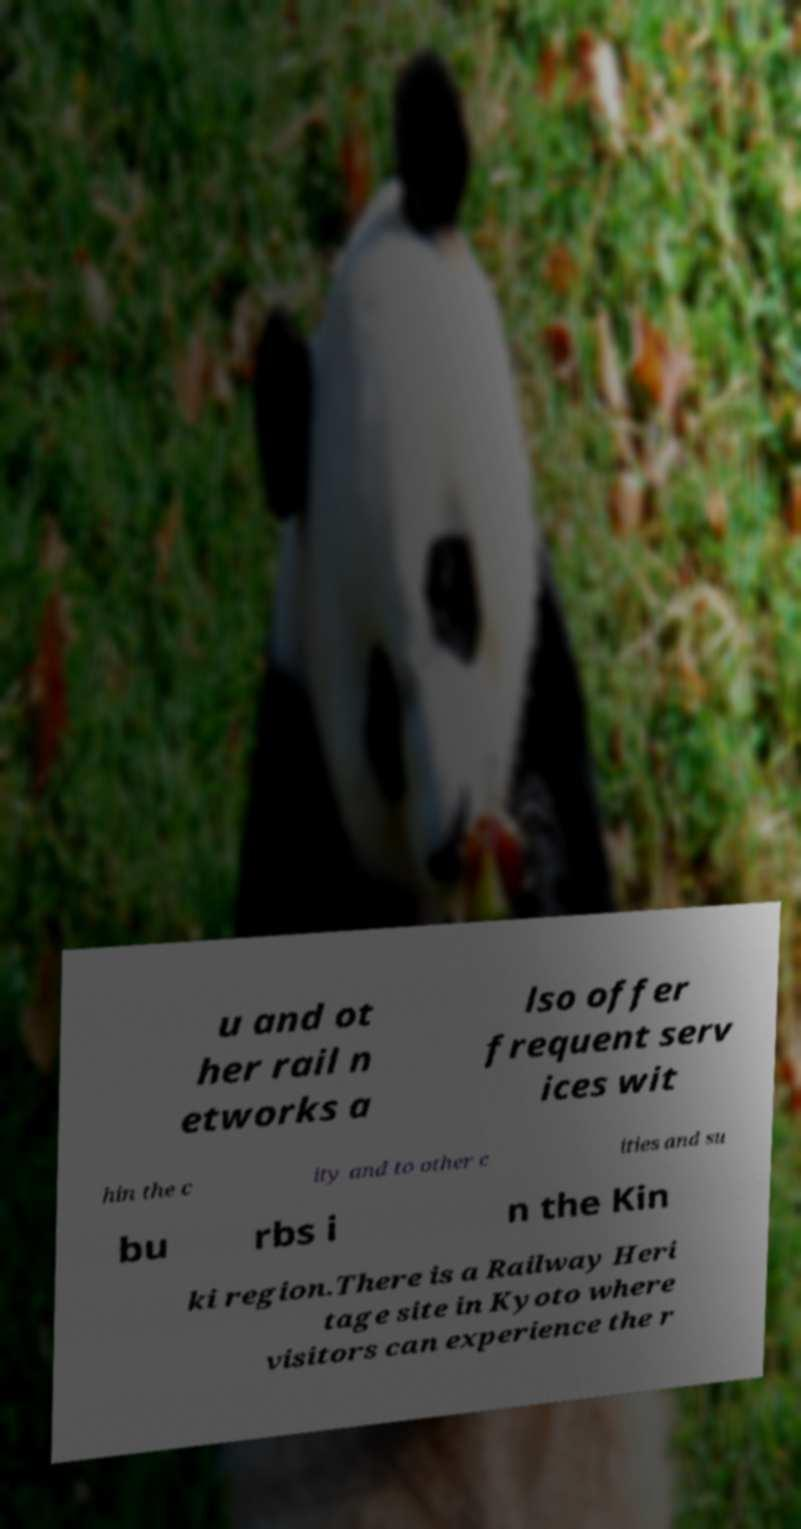Please read and relay the text visible in this image. What does it say? u and ot her rail n etworks a lso offer frequent serv ices wit hin the c ity and to other c ities and su bu rbs i n the Kin ki region.There is a Railway Heri tage site in Kyoto where visitors can experience the r 